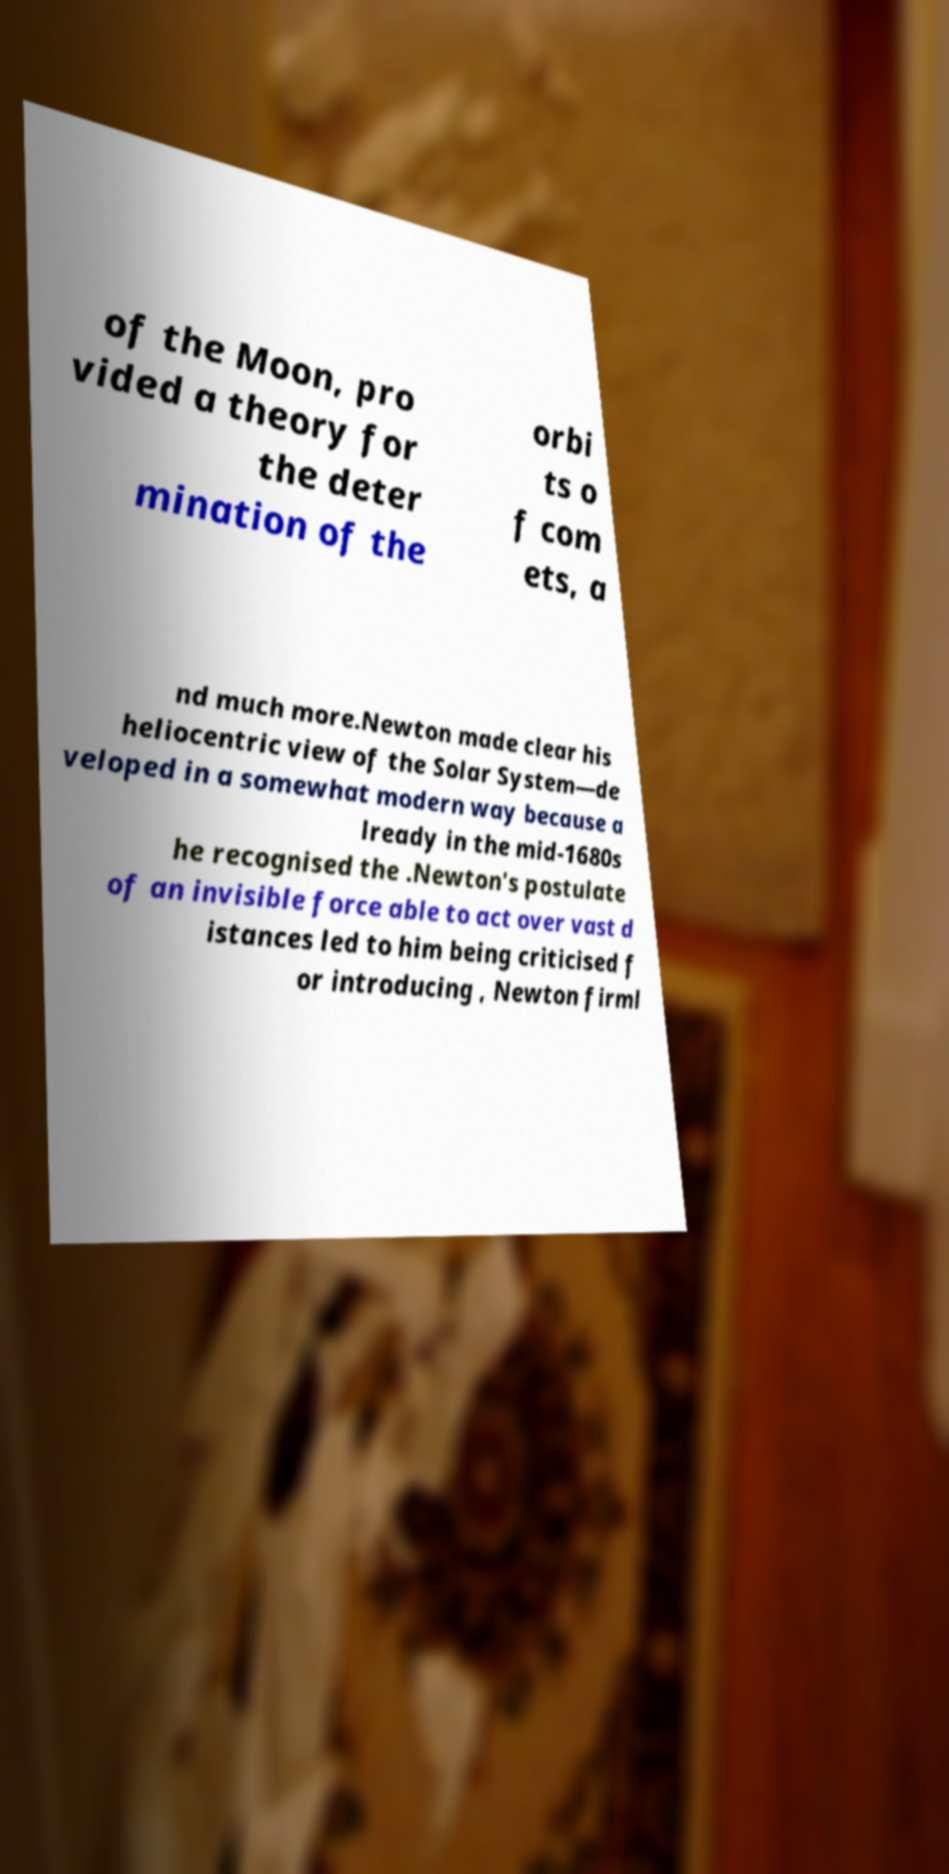For documentation purposes, I need the text within this image transcribed. Could you provide that? of the Moon, pro vided a theory for the deter mination of the orbi ts o f com ets, a nd much more.Newton made clear his heliocentric view of the Solar System—de veloped in a somewhat modern way because a lready in the mid-1680s he recognised the .Newton's postulate of an invisible force able to act over vast d istances led to him being criticised f or introducing , Newton firml 